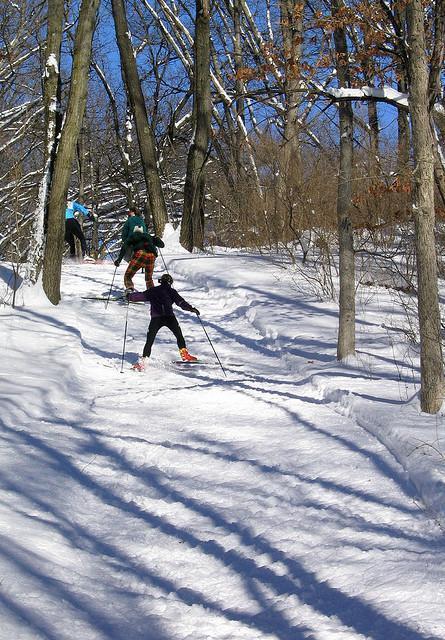How many blue truck cabs are there?
Give a very brief answer. 0. 